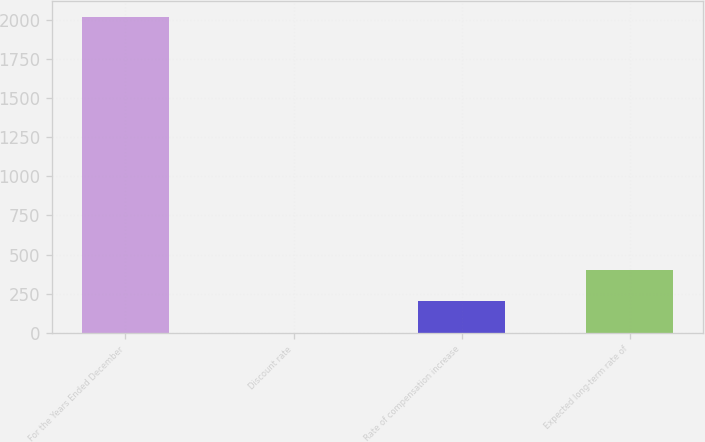Convert chart to OTSL. <chart><loc_0><loc_0><loc_500><loc_500><bar_chart><fcel>For the Years Ended December<fcel>Discount rate<fcel>Rate of compensation increase<fcel>Expected long-term rate of<nl><fcel>2015<fcel>1.94<fcel>203.25<fcel>404.56<nl></chart> 